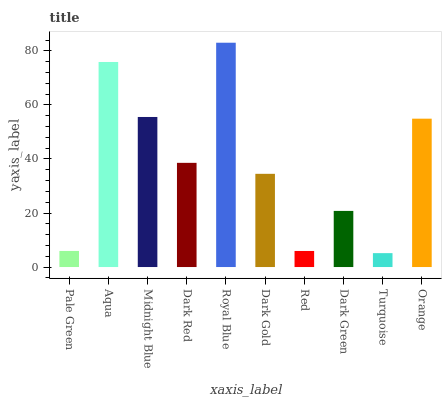Is Turquoise the minimum?
Answer yes or no. Yes. Is Royal Blue the maximum?
Answer yes or no. Yes. Is Aqua the minimum?
Answer yes or no. No. Is Aqua the maximum?
Answer yes or no. No. Is Aqua greater than Pale Green?
Answer yes or no. Yes. Is Pale Green less than Aqua?
Answer yes or no. Yes. Is Pale Green greater than Aqua?
Answer yes or no. No. Is Aqua less than Pale Green?
Answer yes or no. No. Is Dark Red the high median?
Answer yes or no. Yes. Is Dark Gold the low median?
Answer yes or no. Yes. Is Midnight Blue the high median?
Answer yes or no. No. Is Aqua the low median?
Answer yes or no. No. 